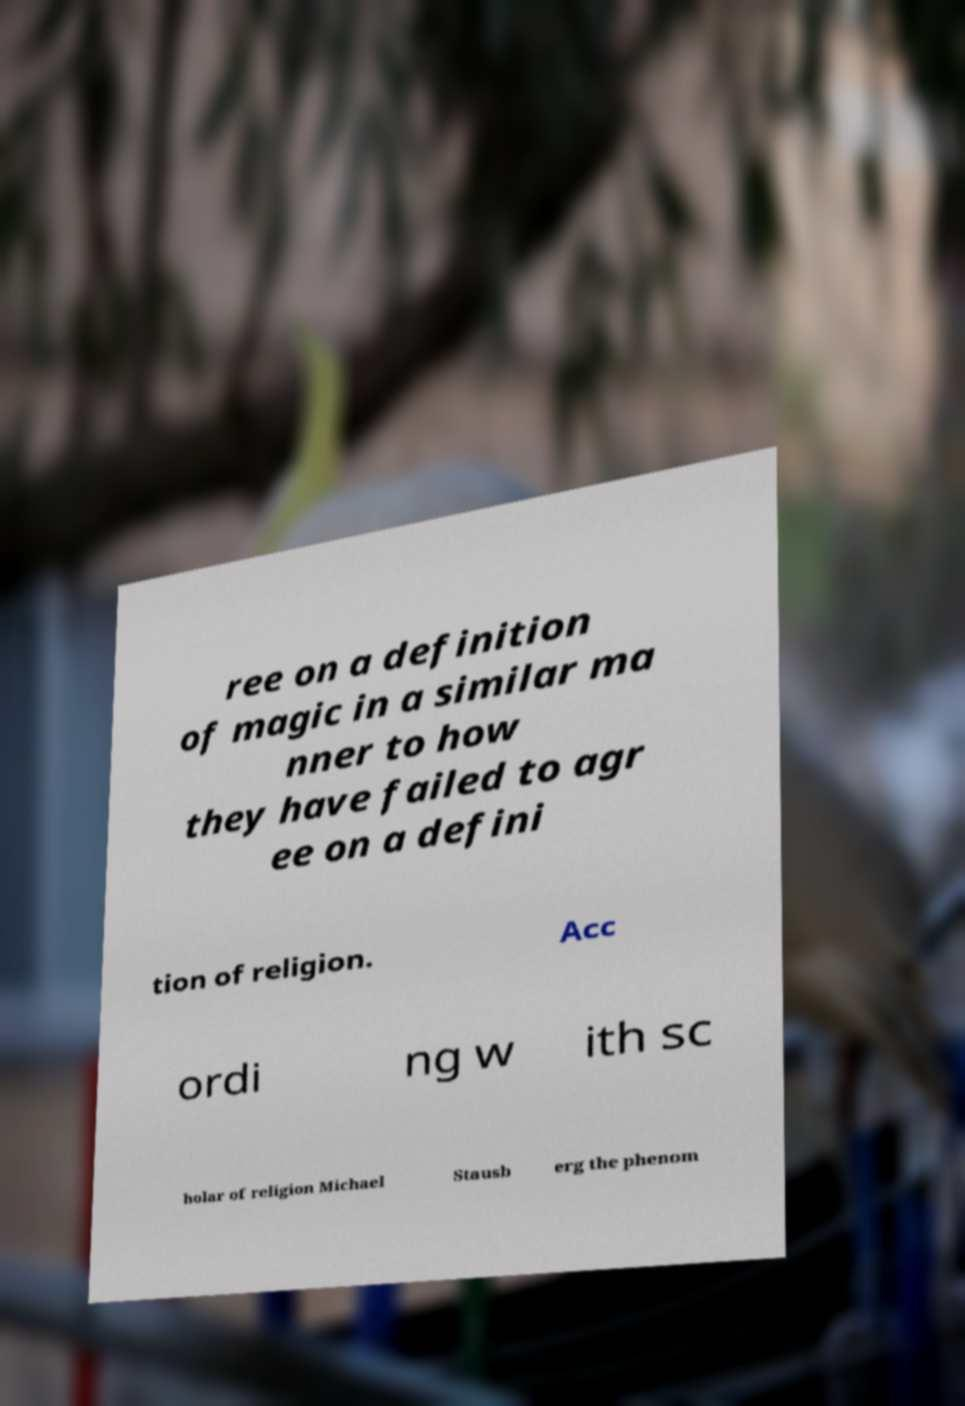For documentation purposes, I need the text within this image transcribed. Could you provide that? ree on a definition of magic in a similar ma nner to how they have failed to agr ee on a defini tion of religion. Acc ordi ng w ith sc holar of religion Michael Stausb erg the phenom 